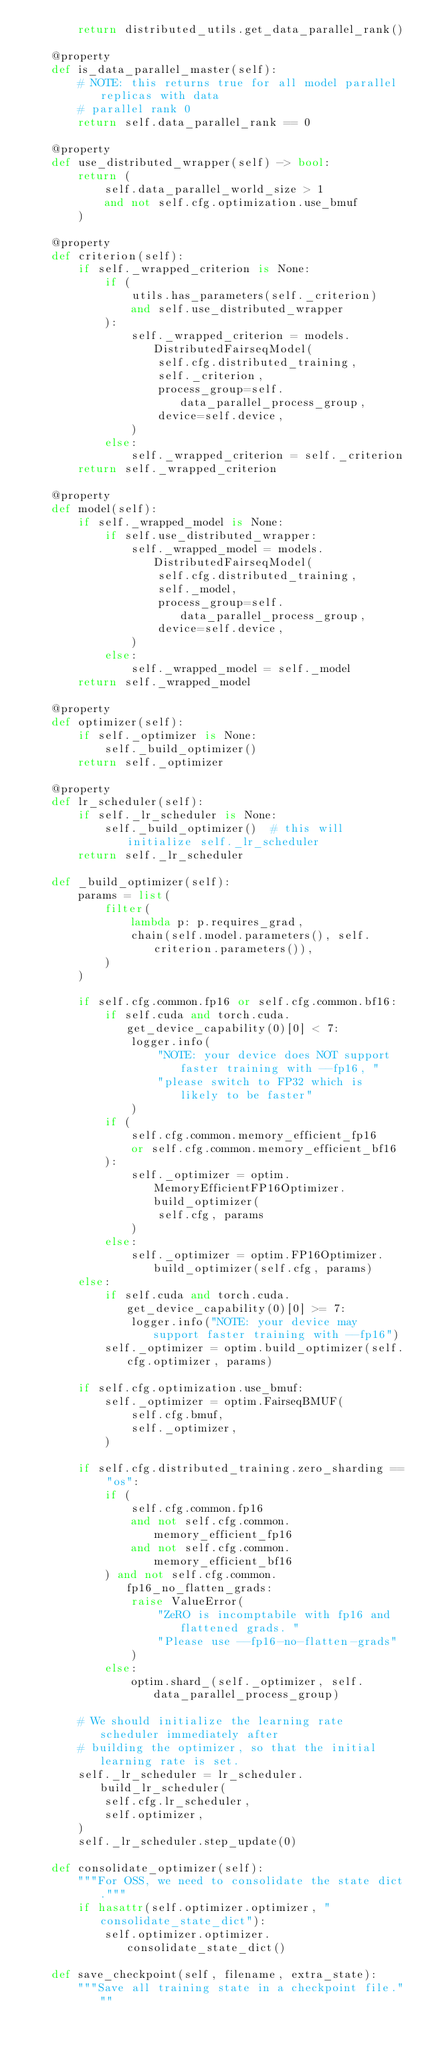<code> <loc_0><loc_0><loc_500><loc_500><_Python_>        return distributed_utils.get_data_parallel_rank()

    @property
    def is_data_parallel_master(self):
        # NOTE: this returns true for all model parallel replicas with data
        # parallel rank 0
        return self.data_parallel_rank == 0

    @property
    def use_distributed_wrapper(self) -> bool:
        return (
            self.data_parallel_world_size > 1
            and not self.cfg.optimization.use_bmuf
        )

    @property
    def criterion(self):
        if self._wrapped_criterion is None:
            if (
                utils.has_parameters(self._criterion)
                and self.use_distributed_wrapper
            ):
                self._wrapped_criterion = models.DistributedFairseqModel(
                    self.cfg.distributed_training,
                    self._criterion,
                    process_group=self.data_parallel_process_group,
                    device=self.device,
                )
            else:
                self._wrapped_criterion = self._criterion
        return self._wrapped_criterion

    @property
    def model(self):
        if self._wrapped_model is None:
            if self.use_distributed_wrapper:
                self._wrapped_model = models.DistributedFairseqModel(
                    self.cfg.distributed_training,
                    self._model,
                    process_group=self.data_parallel_process_group,
                    device=self.device,
                )
            else:
                self._wrapped_model = self._model
        return self._wrapped_model

    @property
    def optimizer(self):
        if self._optimizer is None:
            self._build_optimizer()
        return self._optimizer

    @property
    def lr_scheduler(self):
        if self._lr_scheduler is None:
            self._build_optimizer()  # this will initialize self._lr_scheduler
        return self._lr_scheduler

    def _build_optimizer(self):
        params = list(
            filter(
                lambda p: p.requires_grad,
                chain(self.model.parameters(), self.criterion.parameters()),
            )
        )

        if self.cfg.common.fp16 or self.cfg.common.bf16:
            if self.cuda and torch.cuda.get_device_capability(0)[0] < 7:
                logger.info(
                    "NOTE: your device does NOT support faster training with --fp16, "
                    "please switch to FP32 which is likely to be faster"
                )
            if (
                self.cfg.common.memory_efficient_fp16
                or self.cfg.common.memory_efficient_bf16
            ):
                self._optimizer = optim.MemoryEfficientFP16Optimizer.build_optimizer(
                    self.cfg, params
                )
            else:
                self._optimizer = optim.FP16Optimizer.build_optimizer(self.cfg, params)
        else:
            if self.cuda and torch.cuda.get_device_capability(0)[0] >= 7:
                logger.info("NOTE: your device may support faster training with --fp16")
            self._optimizer = optim.build_optimizer(self.cfg.optimizer, params)

        if self.cfg.optimization.use_bmuf:
            self._optimizer = optim.FairseqBMUF(
                self.cfg.bmuf,
                self._optimizer,
            )

        if self.cfg.distributed_training.zero_sharding == "os":
            if (
                self.cfg.common.fp16
                and not self.cfg.common.memory_efficient_fp16
                and not self.cfg.common.memory_efficient_bf16
            ) and not self.cfg.common.fp16_no_flatten_grads:
                raise ValueError(
                    "ZeRO is incomptabile with fp16 and flattened grads. "
                    "Please use --fp16-no-flatten-grads"
                )
            else:
                optim.shard_(self._optimizer, self.data_parallel_process_group)

        # We should initialize the learning rate scheduler immediately after
        # building the optimizer, so that the initial learning rate is set.
        self._lr_scheduler = lr_scheduler.build_lr_scheduler(
            self.cfg.lr_scheduler,
            self.optimizer,
        )
        self._lr_scheduler.step_update(0)

    def consolidate_optimizer(self):
        """For OSS, we need to consolidate the state dict."""
        if hasattr(self.optimizer.optimizer, "consolidate_state_dict"):
            self.optimizer.optimizer.consolidate_state_dict()

    def save_checkpoint(self, filename, extra_state):
        """Save all training state in a checkpoint file."""</code> 